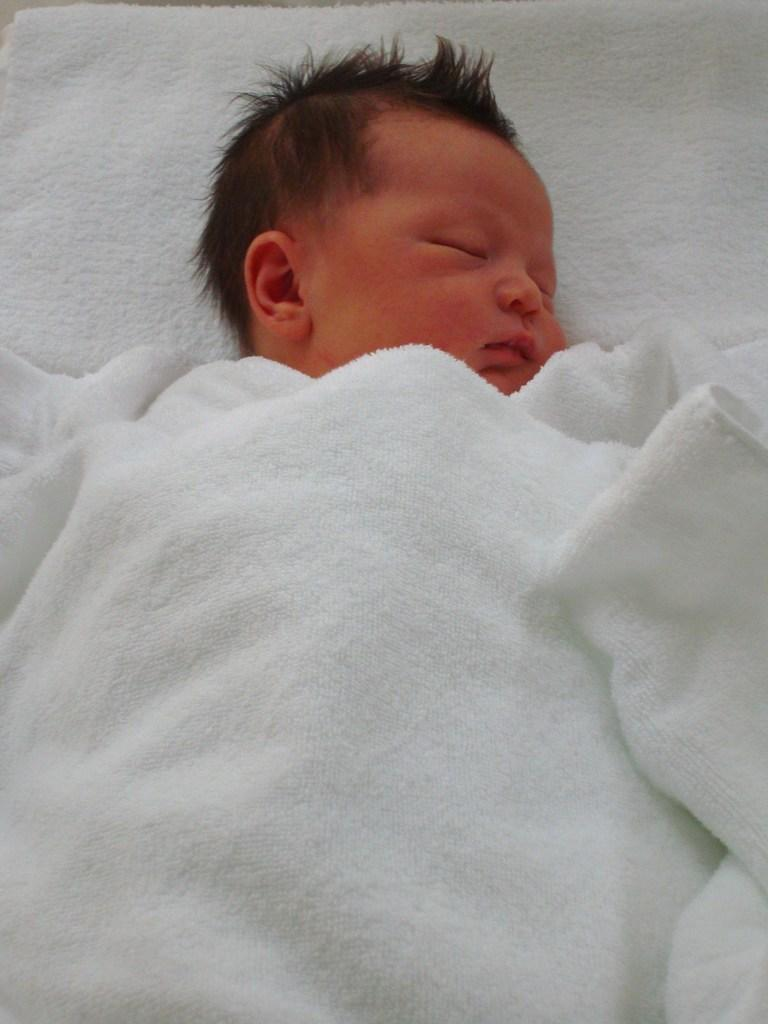What is the main subject of the image? The main subject of the image is a child. Can you describe any other objects or elements in the image? Yes, there is a white cloth in the image. What type of glue is being used by the child in the image? There is no glue present in the image, and the child is not shown using any glue. Can you see the moon in the image? The moon is not visible in the image; it only features a child and a white cloth. 